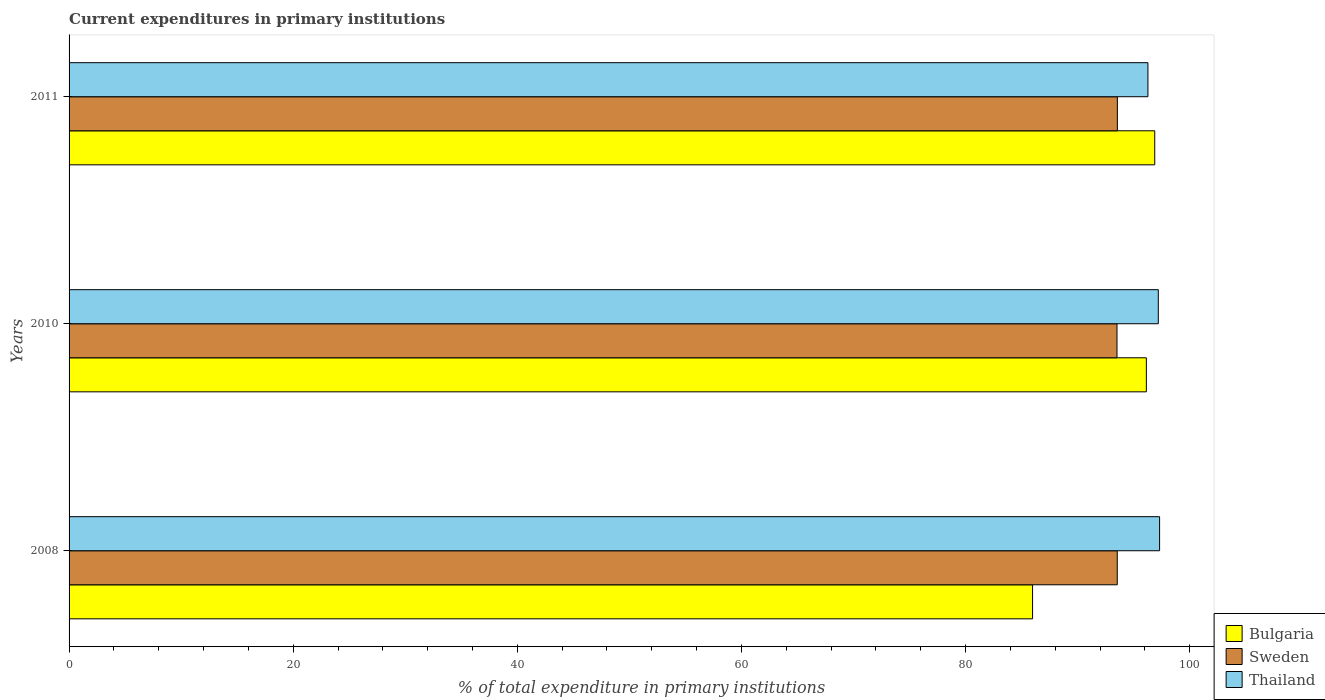How many different coloured bars are there?
Make the answer very short. 3. How many groups of bars are there?
Offer a very short reply. 3. Are the number of bars per tick equal to the number of legend labels?
Make the answer very short. Yes. How many bars are there on the 1st tick from the bottom?
Your response must be concise. 3. What is the current expenditures in primary institutions in Sweden in 2008?
Your response must be concise. 93.54. Across all years, what is the maximum current expenditures in primary institutions in Bulgaria?
Keep it short and to the point. 96.88. Across all years, what is the minimum current expenditures in primary institutions in Bulgaria?
Ensure brevity in your answer.  85.98. In which year was the current expenditures in primary institutions in Sweden maximum?
Ensure brevity in your answer.  2011. In which year was the current expenditures in primary institutions in Bulgaria minimum?
Offer a very short reply. 2008. What is the total current expenditures in primary institutions in Sweden in the graph?
Offer a very short reply. 280.6. What is the difference between the current expenditures in primary institutions in Bulgaria in 2008 and that in 2011?
Provide a short and direct response. -10.9. What is the difference between the current expenditures in primary institutions in Sweden in 2010 and the current expenditures in primary institutions in Bulgaria in 2011?
Make the answer very short. -3.37. What is the average current expenditures in primary institutions in Thailand per year?
Make the answer very short. 96.93. In the year 2010, what is the difference between the current expenditures in primary institutions in Sweden and current expenditures in primary institutions in Bulgaria?
Offer a terse response. -2.62. What is the ratio of the current expenditures in primary institutions in Sweden in 2008 to that in 2011?
Provide a succinct answer. 1. Is the difference between the current expenditures in primary institutions in Sweden in 2008 and 2010 greater than the difference between the current expenditures in primary institutions in Bulgaria in 2008 and 2010?
Ensure brevity in your answer.  Yes. What is the difference between the highest and the second highest current expenditures in primary institutions in Bulgaria?
Your answer should be compact. 0.75. What is the difference between the highest and the lowest current expenditures in primary institutions in Sweden?
Offer a terse response. 0.03. In how many years, is the current expenditures in primary institutions in Sweden greater than the average current expenditures in primary institutions in Sweden taken over all years?
Your answer should be compact. 2. What does the 1st bar from the top in 2008 represents?
Provide a succinct answer. Thailand. What does the 1st bar from the bottom in 2011 represents?
Keep it short and to the point. Bulgaria. How many bars are there?
Keep it short and to the point. 9. How many years are there in the graph?
Ensure brevity in your answer.  3. Are the values on the major ticks of X-axis written in scientific E-notation?
Offer a very short reply. No. Does the graph contain any zero values?
Your response must be concise. No. Where does the legend appear in the graph?
Provide a short and direct response. Bottom right. How many legend labels are there?
Offer a terse response. 3. How are the legend labels stacked?
Your response must be concise. Vertical. What is the title of the graph?
Your answer should be compact. Current expenditures in primary institutions. What is the label or title of the X-axis?
Your answer should be very brief. % of total expenditure in primary institutions. What is the label or title of the Y-axis?
Offer a terse response. Years. What is the % of total expenditure in primary institutions in Bulgaria in 2008?
Ensure brevity in your answer.  85.98. What is the % of total expenditure in primary institutions of Sweden in 2008?
Offer a very short reply. 93.54. What is the % of total expenditure in primary institutions of Thailand in 2008?
Offer a terse response. 97.32. What is the % of total expenditure in primary institutions in Bulgaria in 2010?
Offer a terse response. 96.14. What is the % of total expenditure in primary institutions of Sweden in 2010?
Offer a terse response. 93.52. What is the % of total expenditure in primary institutions of Thailand in 2010?
Give a very brief answer. 97.2. What is the % of total expenditure in primary institutions in Bulgaria in 2011?
Your answer should be compact. 96.88. What is the % of total expenditure in primary institutions of Sweden in 2011?
Make the answer very short. 93.55. What is the % of total expenditure in primary institutions in Thailand in 2011?
Make the answer very short. 96.28. Across all years, what is the maximum % of total expenditure in primary institutions in Bulgaria?
Your response must be concise. 96.88. Across all years, what is the maximum % of total expenditure in primary institutions of Sweden?
Provide a succinct answer. 93.55. Across all years, what is the maximum % of total expenditure in primary institutions in Thailand?
Offer a terse response. 97.32. Across all years, what is the minimum % of total expenditure in primary institutions in Bulgaria?
Provide a succinct answer. 85.98. Across all years, what is the minimum % of total expenditure in primary institutions in Sweden?
Make the answer very short. 93.52. Across all years, what is the minimum % of total expenditure in primary institutions of Thailand?
Make the answer very short. 96.28. What is the total % of total expenditure in primary institutions in Bulgaria in the graph?
Keep it short and to the point. 279. What is the total % of total expenditure in primary institutions in Sweden in the graph?
Provide a short and direct response. 280.6. What is the total % of total expenditure in primary institutions in Thailand in the graph?
Offer a terse response. 290.79. What is the difference between the % of total expenditure in primary institutions in Bulgaria in 2008 and that in 2010?
Your answer should be compact. -10.16. What is the difference between the % of total expenditure in primary institutions of Sweden in 2008 and that in 2010?
Offer a terse response. 0.02. What is the difference between the % of total expenditure in primary institutions in Thailand in 2008 and that in 2010?
Make the answer very short. 0.11. What is the difference between the % of total expenditure in primary institutions in Bulgaria in 2008 and that in 2011?
Your answer should be compact. -10.9. What is the difference between the % of total expenditure in primary institutions in Sweden in 2008 and that in 2011?
Make the answer very short. -0.01. What is the difference between the % of total expenditure in primary institutions of Thailand in 2008 and that in 2011?
Make the answer very short. 1.04. What is the difference between the % of total expenditure in primary institutions in Bulgaria in 2010 and that in 2011?
Keep it short and to the point. -0.75. What is the difference between the % of total expenditure in primary institutions of Sweden in 2010 and that in 2011?
Offer a very short reply. -0.03. What is the difference between the % of total expenditure in primary institutions in Thailand in 2010 and that in 2011?
Offer a terse response. 0.93. What is the difference between the % of total expenditure in primary institutions of Bulgaria in 2008 and the % of total expenditure in primary institutions of Sweden in 2010?
Provide a succinct answer. -7.53. What is the difference between the % of total expenditure in primary institutions of Bulgaria in 2008 and the % of total expenditure in primary institutions of Thailand in 2010?
Give a very brief answer. -11.22. What is the difference between the % of total expenditure in primary institutions in Sweden in 2008 and the % of total expenditure in primary institutions in Thailand in 2010?
Your answer should be very brief. -3.67. What is the difference between the % of total expenditure in primary institutions in Bulgaria in 2008 and the % of total expenditure in primary institutions in Sweden in 2011?
Keep it short and to the point. -7.57. What is the difference between the % of total expenditure in primary institutions of Bulgaria in 2008 and the % of total expenditure in primary institutions of Thailand in 2011?
Your answer should be compact. -10.3. What is the difference between the % of total expenditure in primary institutions of Sweden in 2008 and the % of total expenditure in primary institutions of Thailand in 2011?
Your response must be concise. -2.74. What is the difference between the % of total expenditure in primary institutions in Bulgaria in 2010 and the % of total expenditure in primary institutions in Sweden in 2011?
Give a very brief answer. 2.59. What is the difference between the % of total expenditure in primary institutions of Bulgaria in 2010 and the % of total expenditure in primary institutions of Thailand in 2011?
Your answer should be very brief. -0.14. What is the difference between the % of total expenditure in primary institutions in Sweden in 2010 and the % of total expenditure in primary institutions in Thailand in 2011?
Your answer should be compact. -2.76. What is the average % of total expenditure in primary institutions of Bulgaria per year?
Give a very brief answer. 93. What is the average % of total expenditure in primary institutions of Sweden per year?
Your answer should be compact. 93.53. What is the average % of total expenditure in primary institutions of Thailand per year?
Provide a succinct answer. 96.93. In the year 2008, what is the difference between the % of total expenditure in primary institutions of Bulgaria and % of total expenditure in primary institutions of Sweden?
Provide a short and direct response. -7.56. In the year 2008, what is the difference between the % of total expenditure in primary institutions of Bulgaria and % of total expenditure in primary institutions of Thailand?
Keep it short and to the point. -11.34. In the year 2008, what is the difference between the % of total expenditure in primary institutions of Sweden and % of total expenditure in primary institutions of Thailand?
Your answer should be compact. -3.78. In the year 2010, what is the difference between the % of total expenditure in primary institutions of Bulgaria and % of total expenditure in primary institutions of Sweden?
Offer a very short reply. 2.62. In the year 2010, what is the difference between the % of total expenditure in primary institutions of Bulgaria and % of total expenditure in primary institutions of Thailand?
Give a very brief answer. -1.07. In the year 2010, what is the difference between the % of total expenditure in primary institutions of Sweden and % of total expenditure in primary institutions of Thailand?
Ensure brevity in your answer.  -3.69. In the year 2011, what is the difference between the % of total expenditure in primary institutions of Bulgaria and % of total expenditure in primary institutions of Sweden?
Your response must be concise. 3.34. In the year 2011, what is the difference between the % of total expenditure in primary institutions of Bulgaria and % of total expenditure in primary institutions of Thailand?
Ensure brevity in your answer.  0.61. In the year 2011, what is the difference between the % of total expenditure in primary institutions in Sweden and % of total expenditure in primary institutions in Thailand?
Make the answer very short. -2.73. What is the ratio of the % of total expenditure in primary institutions of Bulgaria in 2008 to that in 2010?
Offer a terse response. 0.89. What is the ratio of the % of total expenditure in primary institutions in Sweden in 2008 to that in 2010?
Offer a very short reply. 1. What is the ratio of the % of total expenditure in primary institutions in Bulgaria in 2008 to that in 2011?
Offer a terse response. 0.89. What is the ratio of the % of total expenditure in primary institutions in Sweden in 2008 to that in 2011?
Offer a terse response. 1. What is the ratio of the % of total expenditure in primary institutions of Thailand in 2008 to that in 2011?
Keep it short and to the point. 1.01. What is the ratio of the % of total expenditure in primary institutions in Sweden in 2010 to that in 2011?
Make the answer very short. 1. What is the ratio of the % of total expenditure in primary institutions in Thailand in 2010 to that in 2011?
Your answer should be very brief. 1.01. What is the difference between the highest and the second highest % of total expenditure in primary institutions of Bulgaria?
Give a very brief answer. 0.75. What is the difference between the highest and the second highest % of total expenditure in primary institutions of Sweden?
Your response must be concise. 0.01. What is the difference between the highest and the second highest % of total expenditure in primary institutions in Thailand?
Offer a terse response. 0.11. What is the difference between the highest and the lowest % of total expenditure in primary institutions of Bulgaria?
Provide a succinct answer. 10.9. What is the difference between the highest and the lowest % of total expenditure in primary institutions of Sweden?
Keep it short and to the point. 0.03. What is the difference between the highest and the lowest % of total expenditure in primary institutions in Thailand?
Keep it short and to the point. 1.04. 